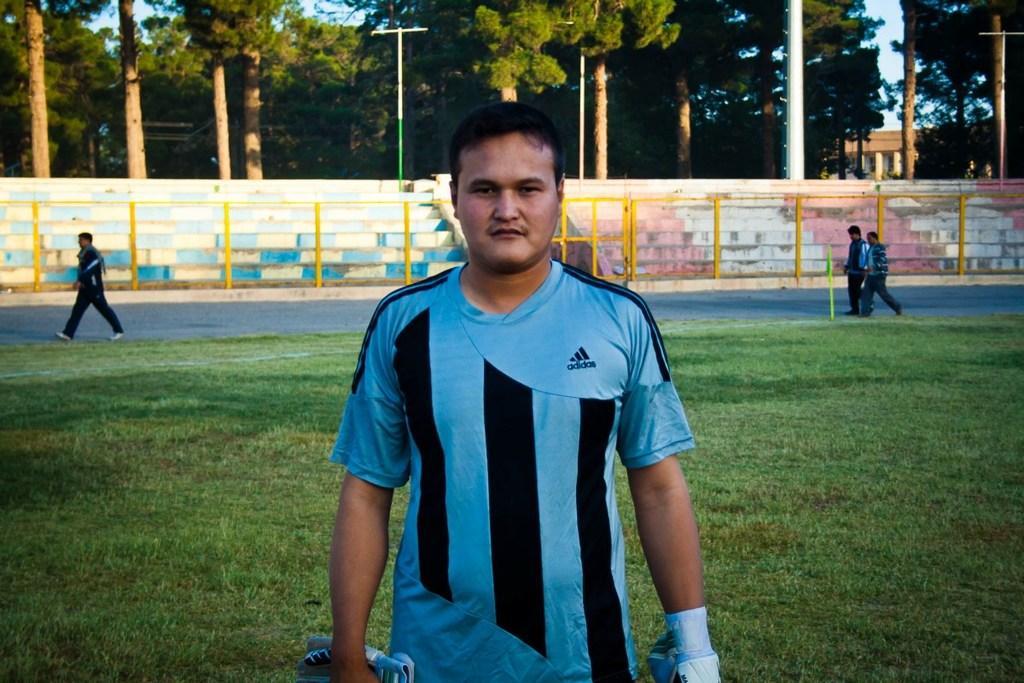Could you give a brief overview of what you see in this image? In the center of the image we can see a man standing. In the background there are trees, wall and a fence. There are people walking on the road and there is sky. At the bottom there is grass. 